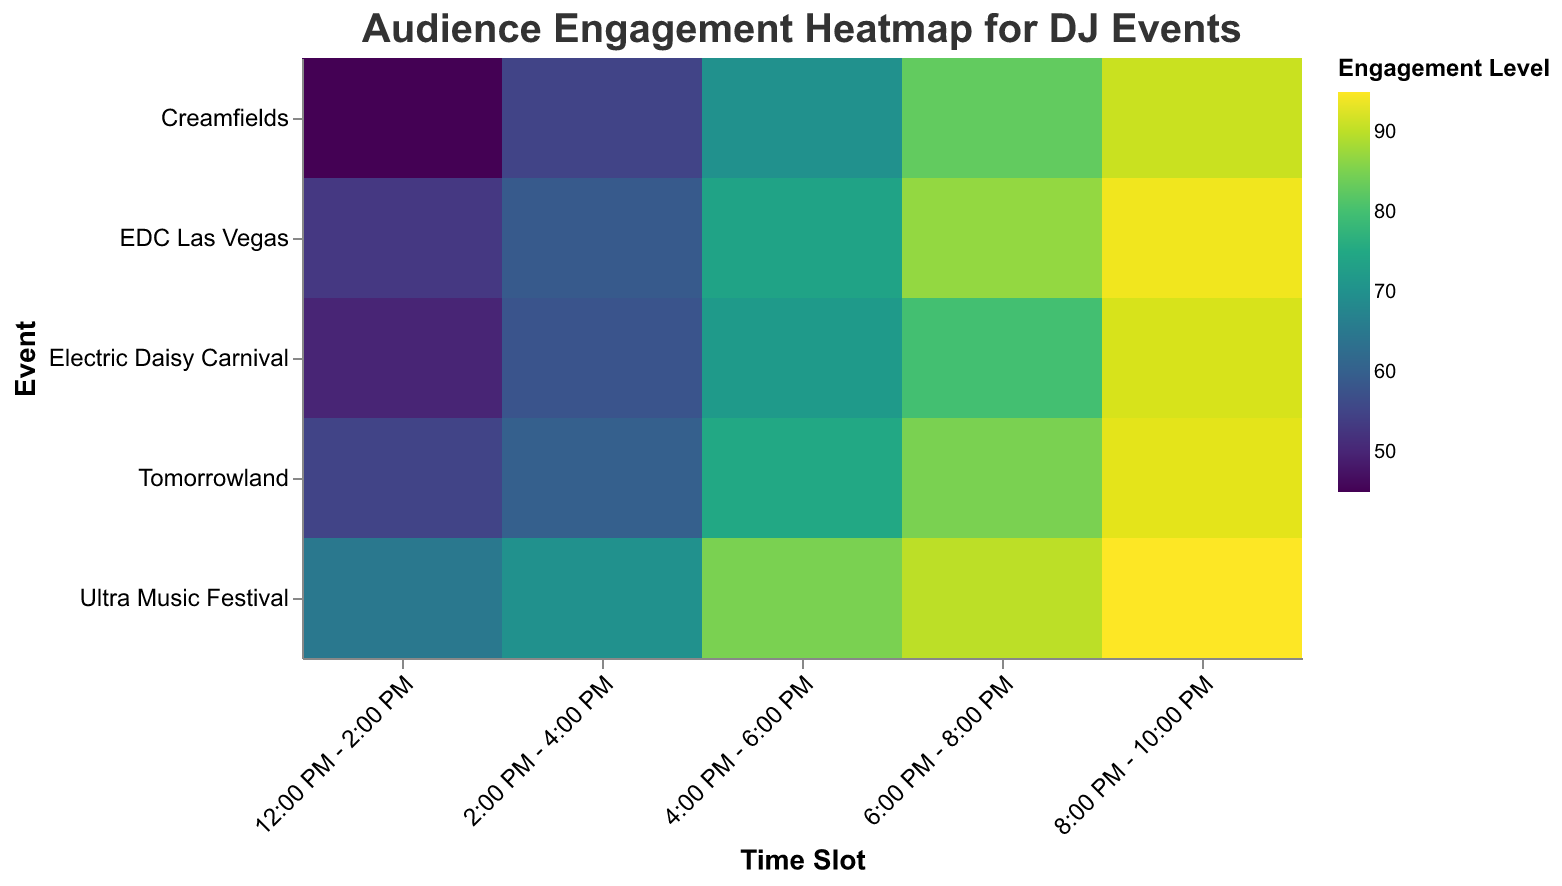Which event shows the highest audience engagement level? The color scheme indicates that darker colors correspond to higher engagement levels. By identifying the darkest color, we can see that the "Ultra Music Festival" has the highest audience engagement level.
Answer: Ultra Music Festival What is the audience engagement level for Tomorrowland between 8:00 PM and 10:00 PM? Look for the cell where "Tomorrowland" intersects with the "8:00 PM - 10:00 PM" time slot. The engagement level is shown as 93.
Answer: 93 Which time slot generally has the lowest audience engagement across all events? Look at the color intensities across each time slot and identify the one with the lightest colors, indicating lower engagement levels. The "12:00 PM - 2:00 PM" slot has the lowest levels overall.
Answer: 12:00 PM - 2:00 PM How does the audience engagement level at EDC Las Vegas from 4:00 PM to 6:00 PM compare to Creamfields from 6:00 PM to 8:00 PM? Check the engagement levels for those cells. EDC Las Vegas has an engagement level of 74 between 4:00 PM - 6:00 PM, and Creamfields has an engagement level of 83 between 6:00 PM - 8:00 PM. The engagement is higher at Creamfields.
Answer: Creamfields is higher What is the average audience engagement level between 4:00 PM and 6:00 PM across all events? Sum the engagement levels for each event at the 4:00 PM - 6:00 PM slot and divide by the number of events (65+75+72+70+74) / 5 = 71.2.
Answer: 71.2 Which time slot at the Electric Daisy Carnival shows the highest engagement level? Look at all the cells for Electric Daisy Carnival and find the darkest color, indicating the highest engagement. The time slot is "8:00 PM - 10:00 PM" with an engagement level of 92.
Answer: 8:00 PM - 10:00 PM Between Ultra Music Festival and Tomorrowland, which has higher engagement levels in the 6:00 PM - 8:00 PM slot? Compare the engagement levels for both events at 6:00 PM - 8:00 PM. Ultra Music Festival has an engagement of 90, whereas Tomorrowland has 85. Ultra Music Festival is higher.
Answer: Ultra Music Festival What is the difference in audience engagement levels between the 6:00 PM - 8:00 PM and 8:00 PM - 10:00 PM slots at Creamfields? Subtract the engagement level at 6:00 PM - 8:00 PM (83) from the engagement level at 8:00 PM - 10:00 PM (91). The difference is 91 - 83 = 8.
Answer: 8 How does the engagement level at Electric Daisy Carnival between 12:00 PM - 2:00 PM compare to EDC Las Vegas during the same time? Electric Daisy Carnival has an engagement level of 50, while EDC Las Vegas has a level of 53. EDC Las Vegas is slightly higher.
Answer: EDC Las Vegas is higher Which event shows a consistent increase in engagement levels throughout the day? Observe if the engagement levels increase sequentially across all time slots for an event. Ultra Music Festival shows a consistent increase (65, 70, 85, 90, 95) throughout the day.
Answer: Ultra Music Festival 